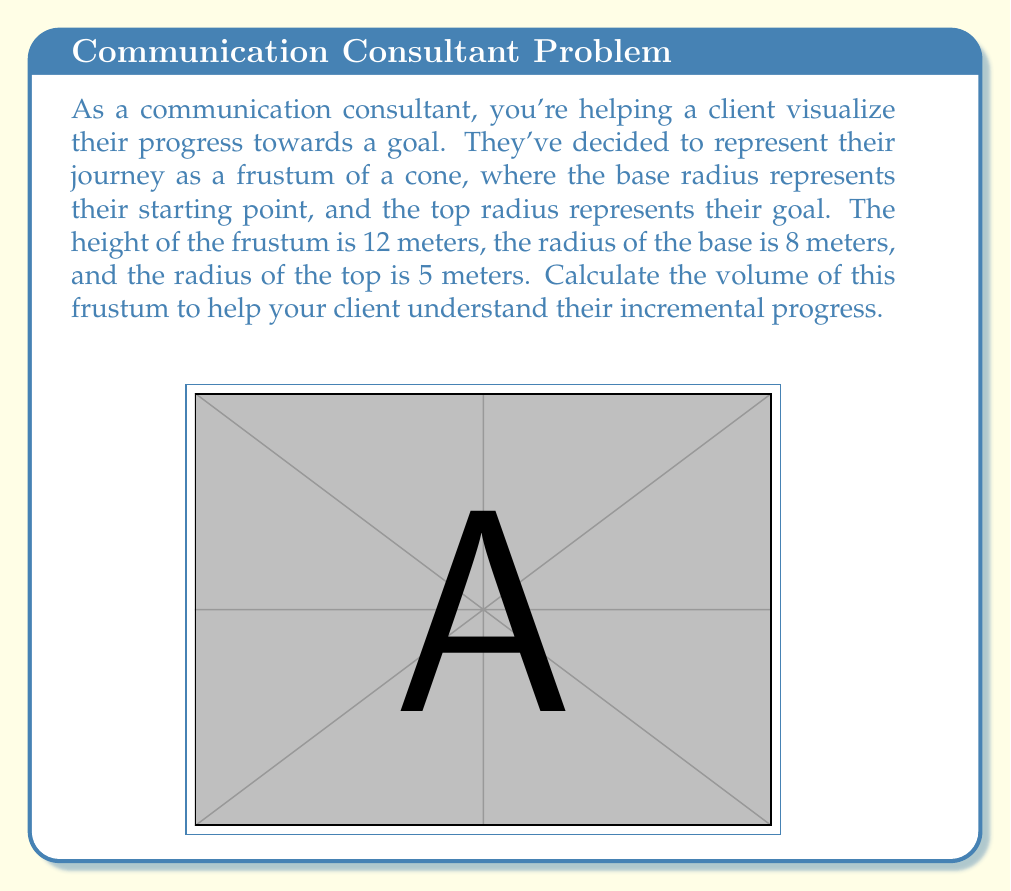Can you solve this math problem? To calculate the volume of a frustum, we can use the formula:

$$V = \frac{1}{3}\pi h(R^2 + r^2 + Rr)$$

Where:
$V$ = volume of the frustum
$h$ = height of the frustum
$R$ = radius of the base
$r$ = radius of the top

Let's substitute the given values:
$h = 12$ meters
$R = 8$ meters
$r = 5$ meters

Now, let's calculate step by step:

1) First, let's square $R$ and $r$:
   $R^2 = 8^2 = 64$
   $r^2 = 5^2 = 25$

2) Now, let's multiply $R$ and $r$:
   $Rr = 8 \times 5 = 40$

3) Let's add these terms:
   $R^2 + r^2 + Rr = 64 + 25 + 40 = 129$

4) Now we can substitute everything into our formula:

   $$V = \frac{1}{3}\pi \times 12 \times 129$$

5) Simplify:
   $$V = 4\pi \times 129 = 516\pi$$

6) If we want to approximate this to a decimal, we can multiply by $\pi \approx 3.14159$:
   $V \approx 516 \times 3.14159 \approx 1621.06$ cubic meters

This volume represents the total progress your client has made. The gradual narrowing of the frustum from base to top can represent how progress often becomes more challenging as one gets closer to their goal, but the volume accumulated still represents significant achievement.
Answer: The volume of the frustum is $516\pi$ cubic meters, or approximately 1621.06 cubic meters. 